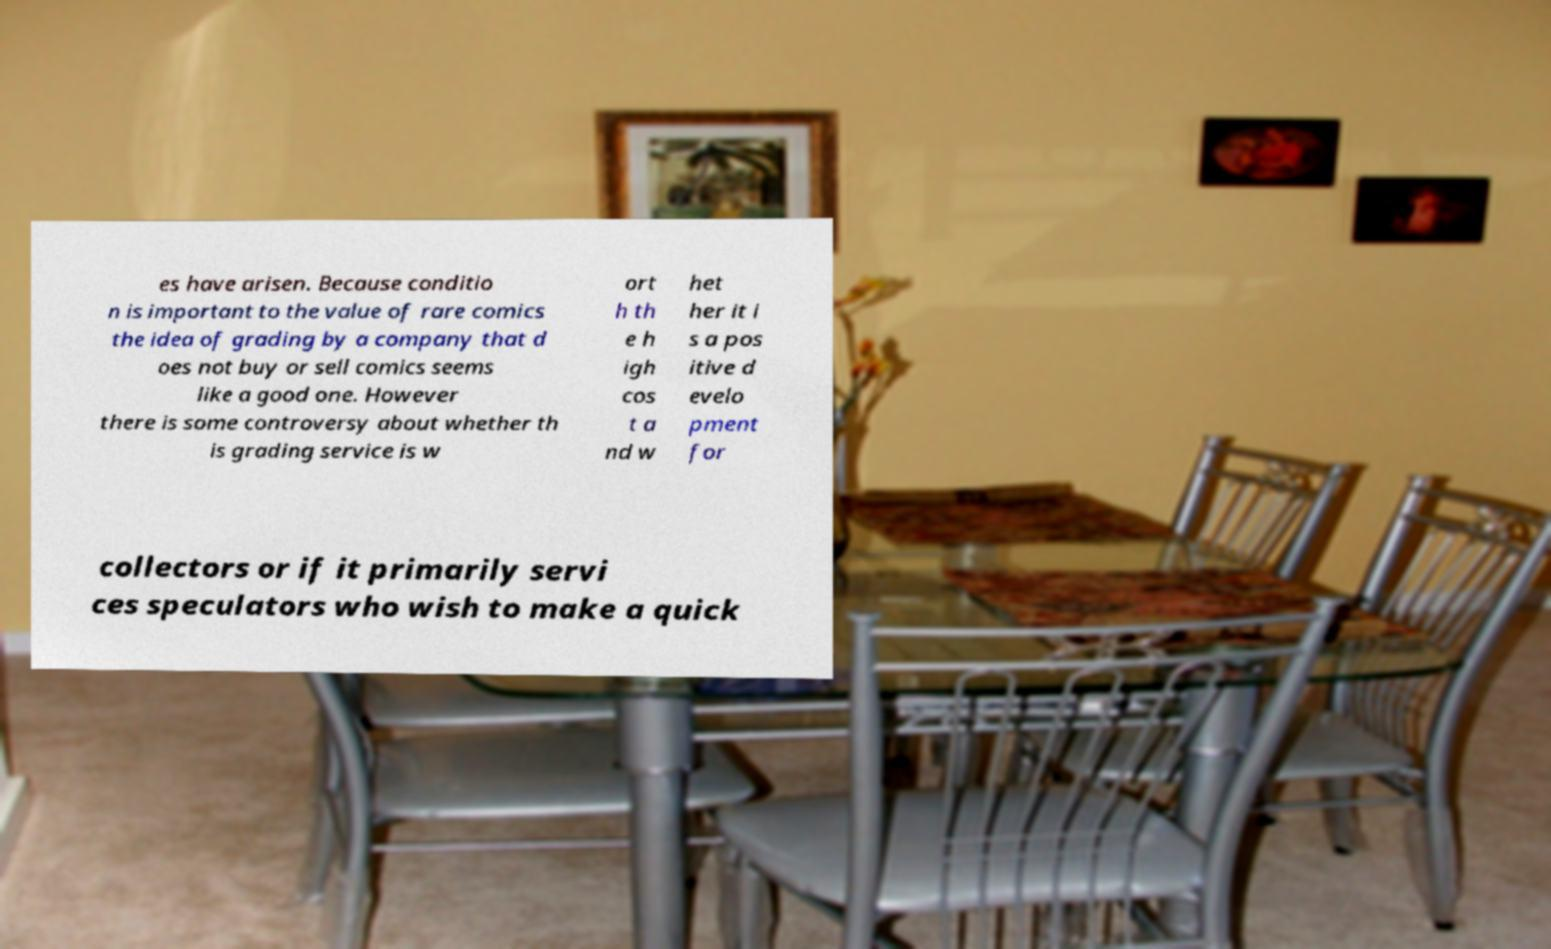Could you assist in decoding the text presented in this image and type it out clearly? es have arisen. Because conditio n is important to the value of rare comics the idea of grading by a company that d oes not buy or sell comics seems like a good one. However there is some controversy about whether th is grading service is w ort h th e h igh cos t a nd w het her it i s a pos itive d evelo pment for collectors or if it primarily servi ces speculators who wish to make a quick 